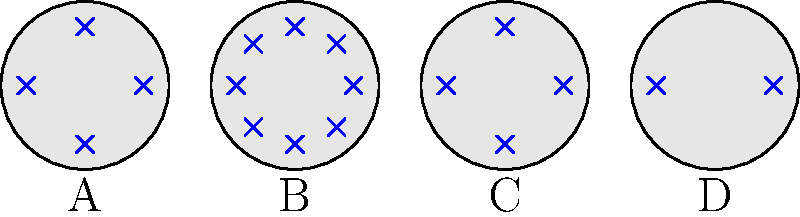In the diagram above, cells A, B, C, and D represent different stages of cell division. Which cell represents the metaphase stage of mitosis, and how many chromosomes are present in the original parent cell? To answer this question, let's break it down step-by-step:

1. First, we need to identify the characteristics of each stage:
   - Cell A: 4 chromosomes, not aligned
   - Cell B: 8 chromosomes, aligned in the center
   - Cell C: 4 chromosomes, not aligned
   - Cell D: 2 chromosomes, not aligned

2. The metaphase stage of mitosis is characterized by chromosomes aligning at the center of the cell. This is most clearly represented by Cell B.

3. To determine the number of chromosomes in the original parent cell, we need to understand the chromosome count during different stages of cell division:
   - During interphase (before division), the cell has its normal chromosome count (2n).
   - During prophase and metaphase of mitosis, the chromosomes have been duplicated but not yet separated, so the count is doubled (4n).
   - During anaphase and telophase, the chromosomes separate, returning to the original count in each daughter cell (2n).

4. Cell B (metaphase) shows 8 chromosomes, which represents the 4n stage. This means the original chromosome count (2n) in the parent cell was half of this, or 4 chromosomes.

Therefore, Cell B represents the metaphase stage, and the original parent cell had 4 chromosomes.
Answer: Cell B; 4 chromosomes 